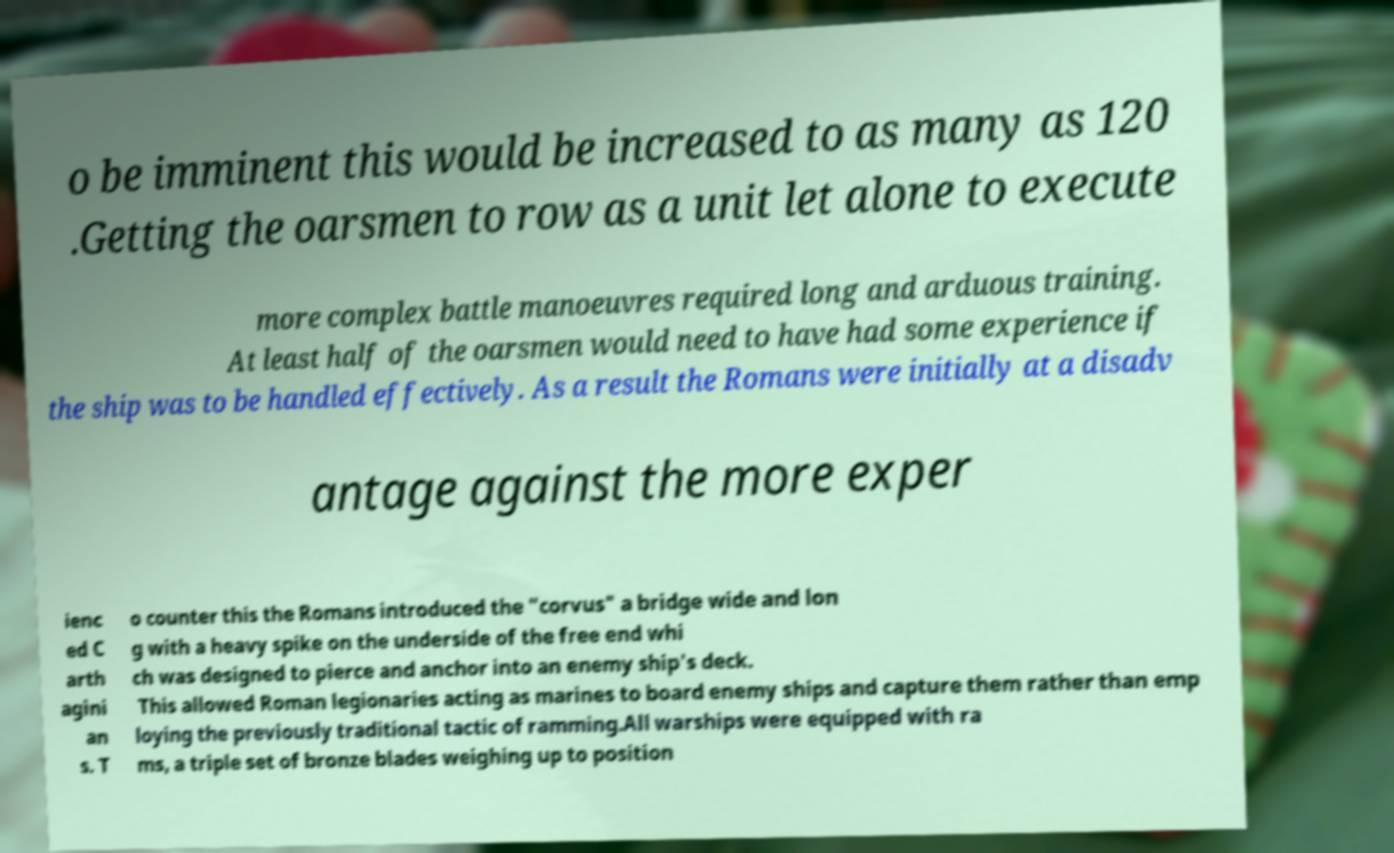For documentation purposes, I need the text within this image transcribed. Could you provide that? o be imminent this would be increased to as many as 120 .Getting the oarsmen to row as a unit let alone to execute more complex battle manoeuvres required long and arduous training. At least half of the oarsmen would need to have had some experience if the ship was to be handled effectively. As a result the Romans were initially at a disadv antage against the more exper ienc ed C arth agini an s. T o counter this the Romans introduced the "corvus" a bridge wide and lon g with a heavy spike on the underside of the free end whi ch was designed to pierce and anchor into an enemy ship's deck. This allowed Roman legionaries acting as marines to board enemy ships and capture them rather than emp loying the previously traditional tactic of ramming.All warships were equipped with ra ms, a triple set of bronze blades weighing up to position 